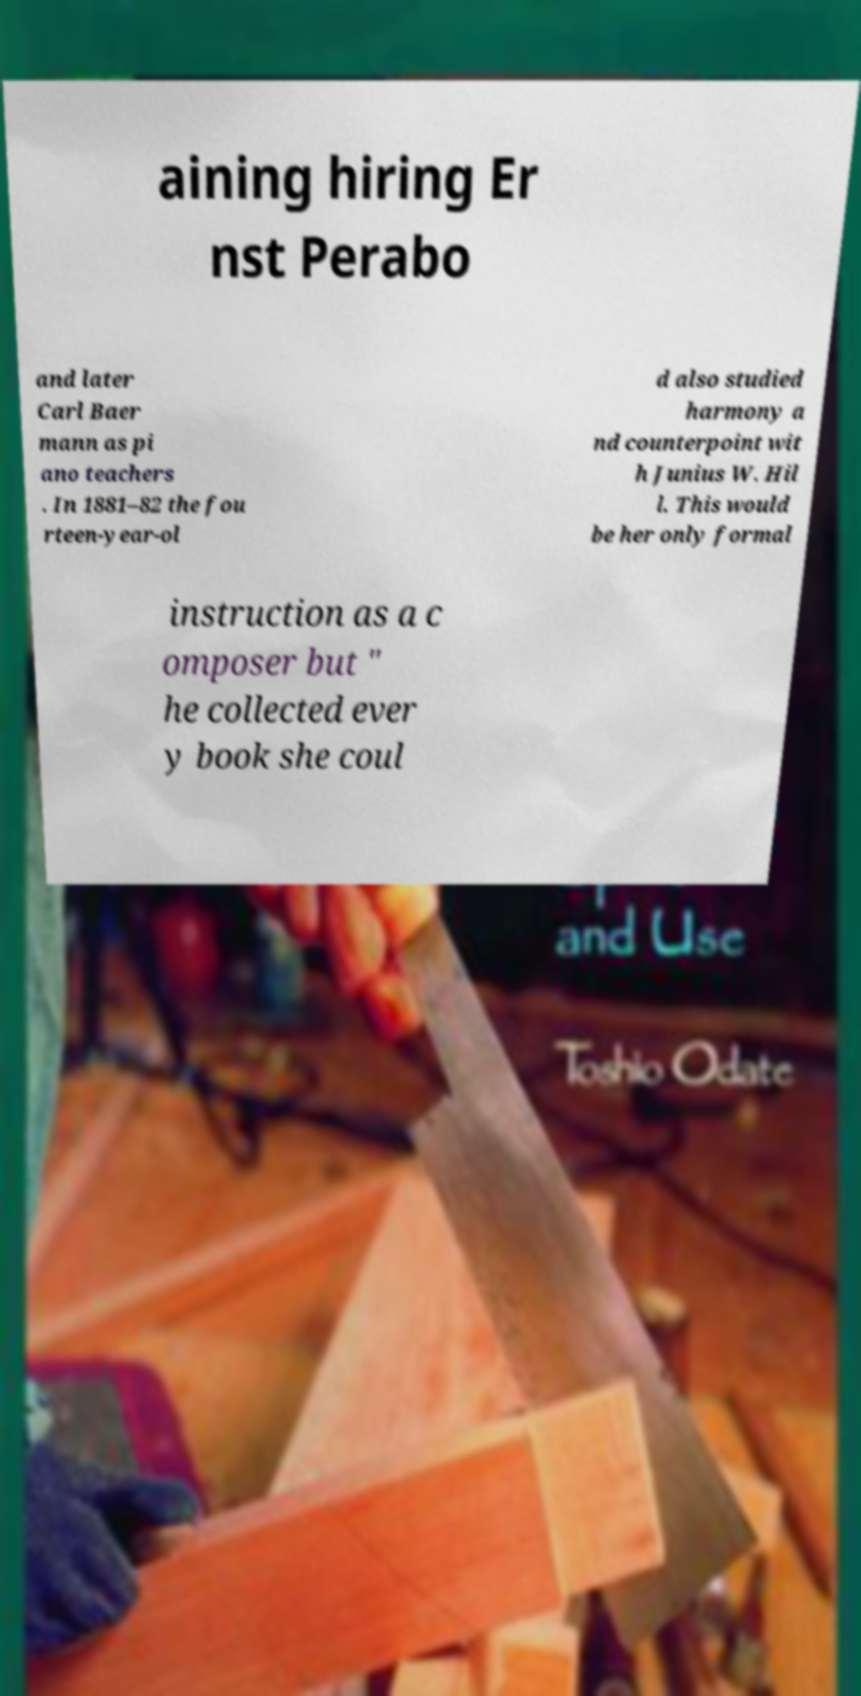Can you accurately transcribe the text from the provided image for me? aining hiring Er nst Perabo and later Carl Baer mann as pi ano teachers . In 1881–82 the fou rteen-year-ol d also studied harmony a nd counterpoint wit h Junius W. Hil l. This would be her only formal instruction as a c omposer but " he collected ever y book she coul 